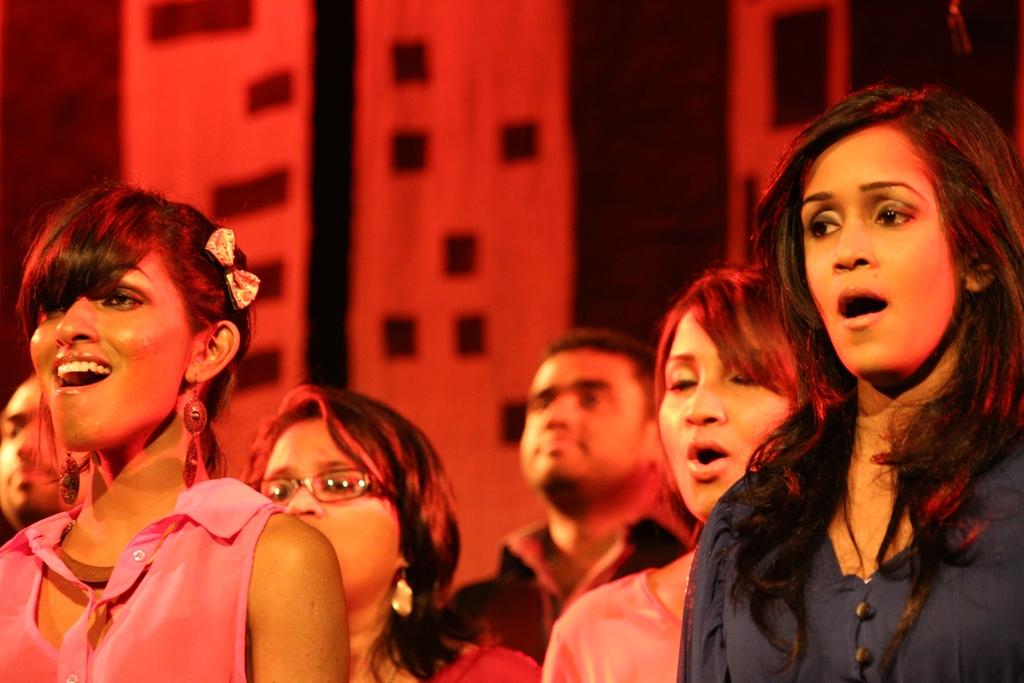What is the main subject of the image? The main subject of the image is a group of people. How can you describe the attire of the people in the image? The people in the image are wearing different color dresses. What colors can be seen in the background of the image? The background of the image has red and black colors visible. How many cars are parked in the background of the image? There are no cars visible in the background of the image. What type of wire is being used by the people in the image? There is no wire present in the image; it features a group of people wearing different color dresses. 